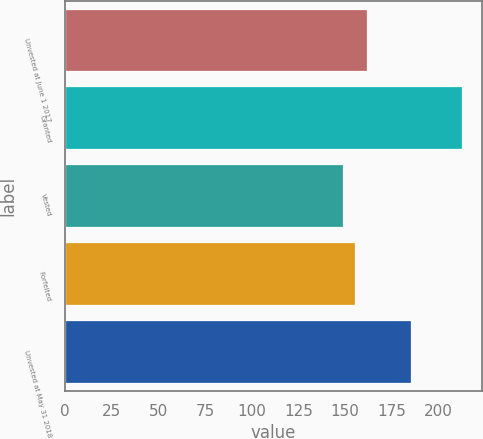Convert chart to OTSL. <chart><loc_0><loc_0><loc_500><loc_500><bar_chart><fcel>Unvested at June 1 2017<fcel>Granted<fcel>Vested<fcel>Forfeited<fcel>Unvested at May 31 2018<nl><fcel>161.68<fcel>212.6<fcel>148.94<fcel>155.31<fcel>185.16<nl></chart> 